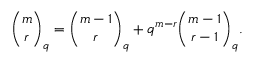Convert formula to latex. <formula><loc_0><loc_0><loc_500><loc_500>{ \binom { m } { r } } _ { q } = { \binom { m - 1 } { r } } _ { q } + q ^ { m - r } { \binom { m - 1 } { r - 1 } } _ { q } .</formula> 